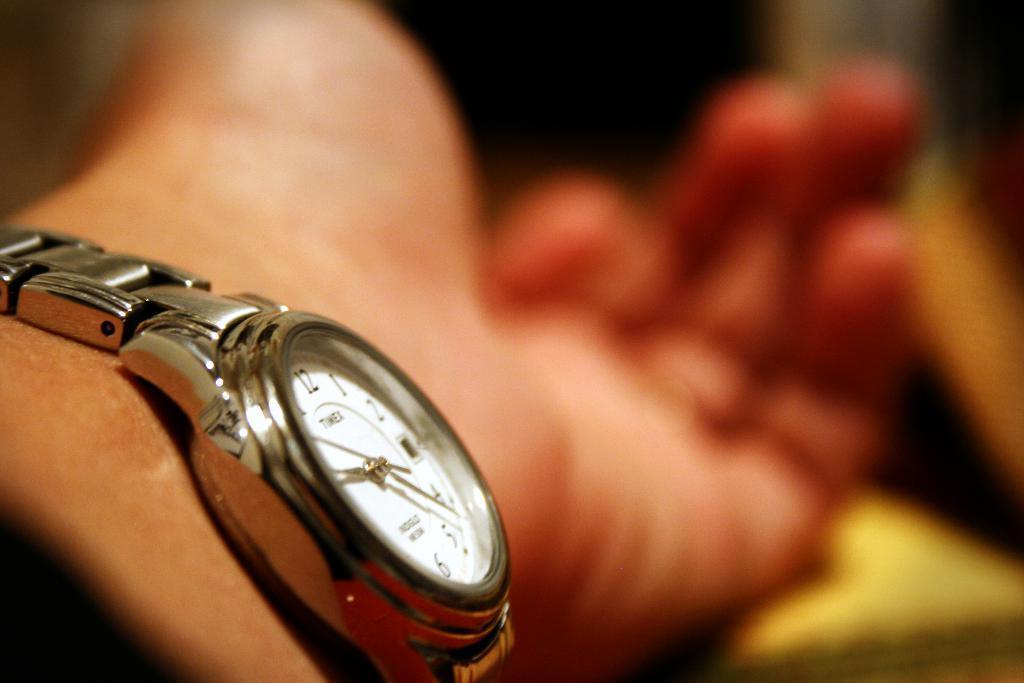Could you give a brief overview of what you see in this image? In this image, I can see a wristwatch to a person's hand. There is a blurred background. 